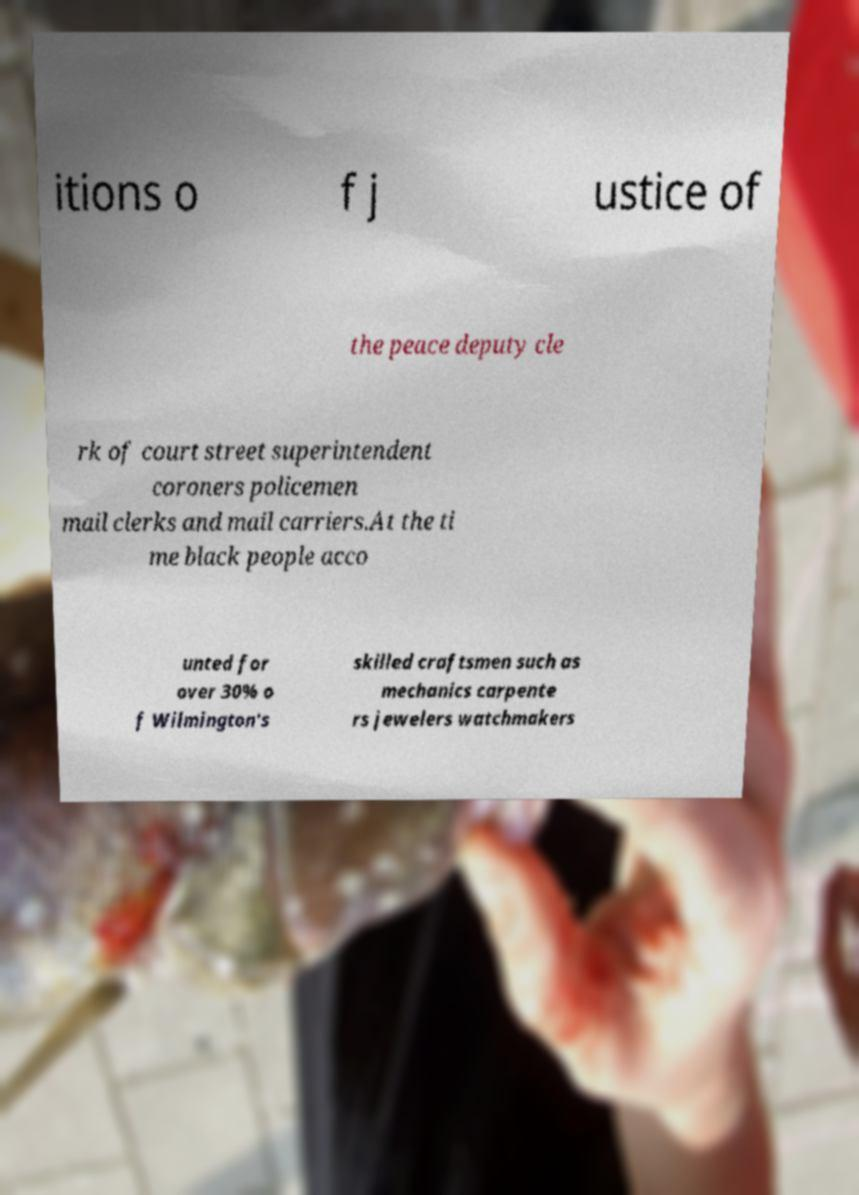What messages or text are displayed in this image? I need them in a readable, typed format. itions o f j ustice of the peace deputy cle rk of court street superintendent coroners policemen mail clerks and mail carriers.At the ti me black people acco unted for over 30% o f Wilmington's skilled craftsmen such as mechanics carpente rs jewelers watchmakers 